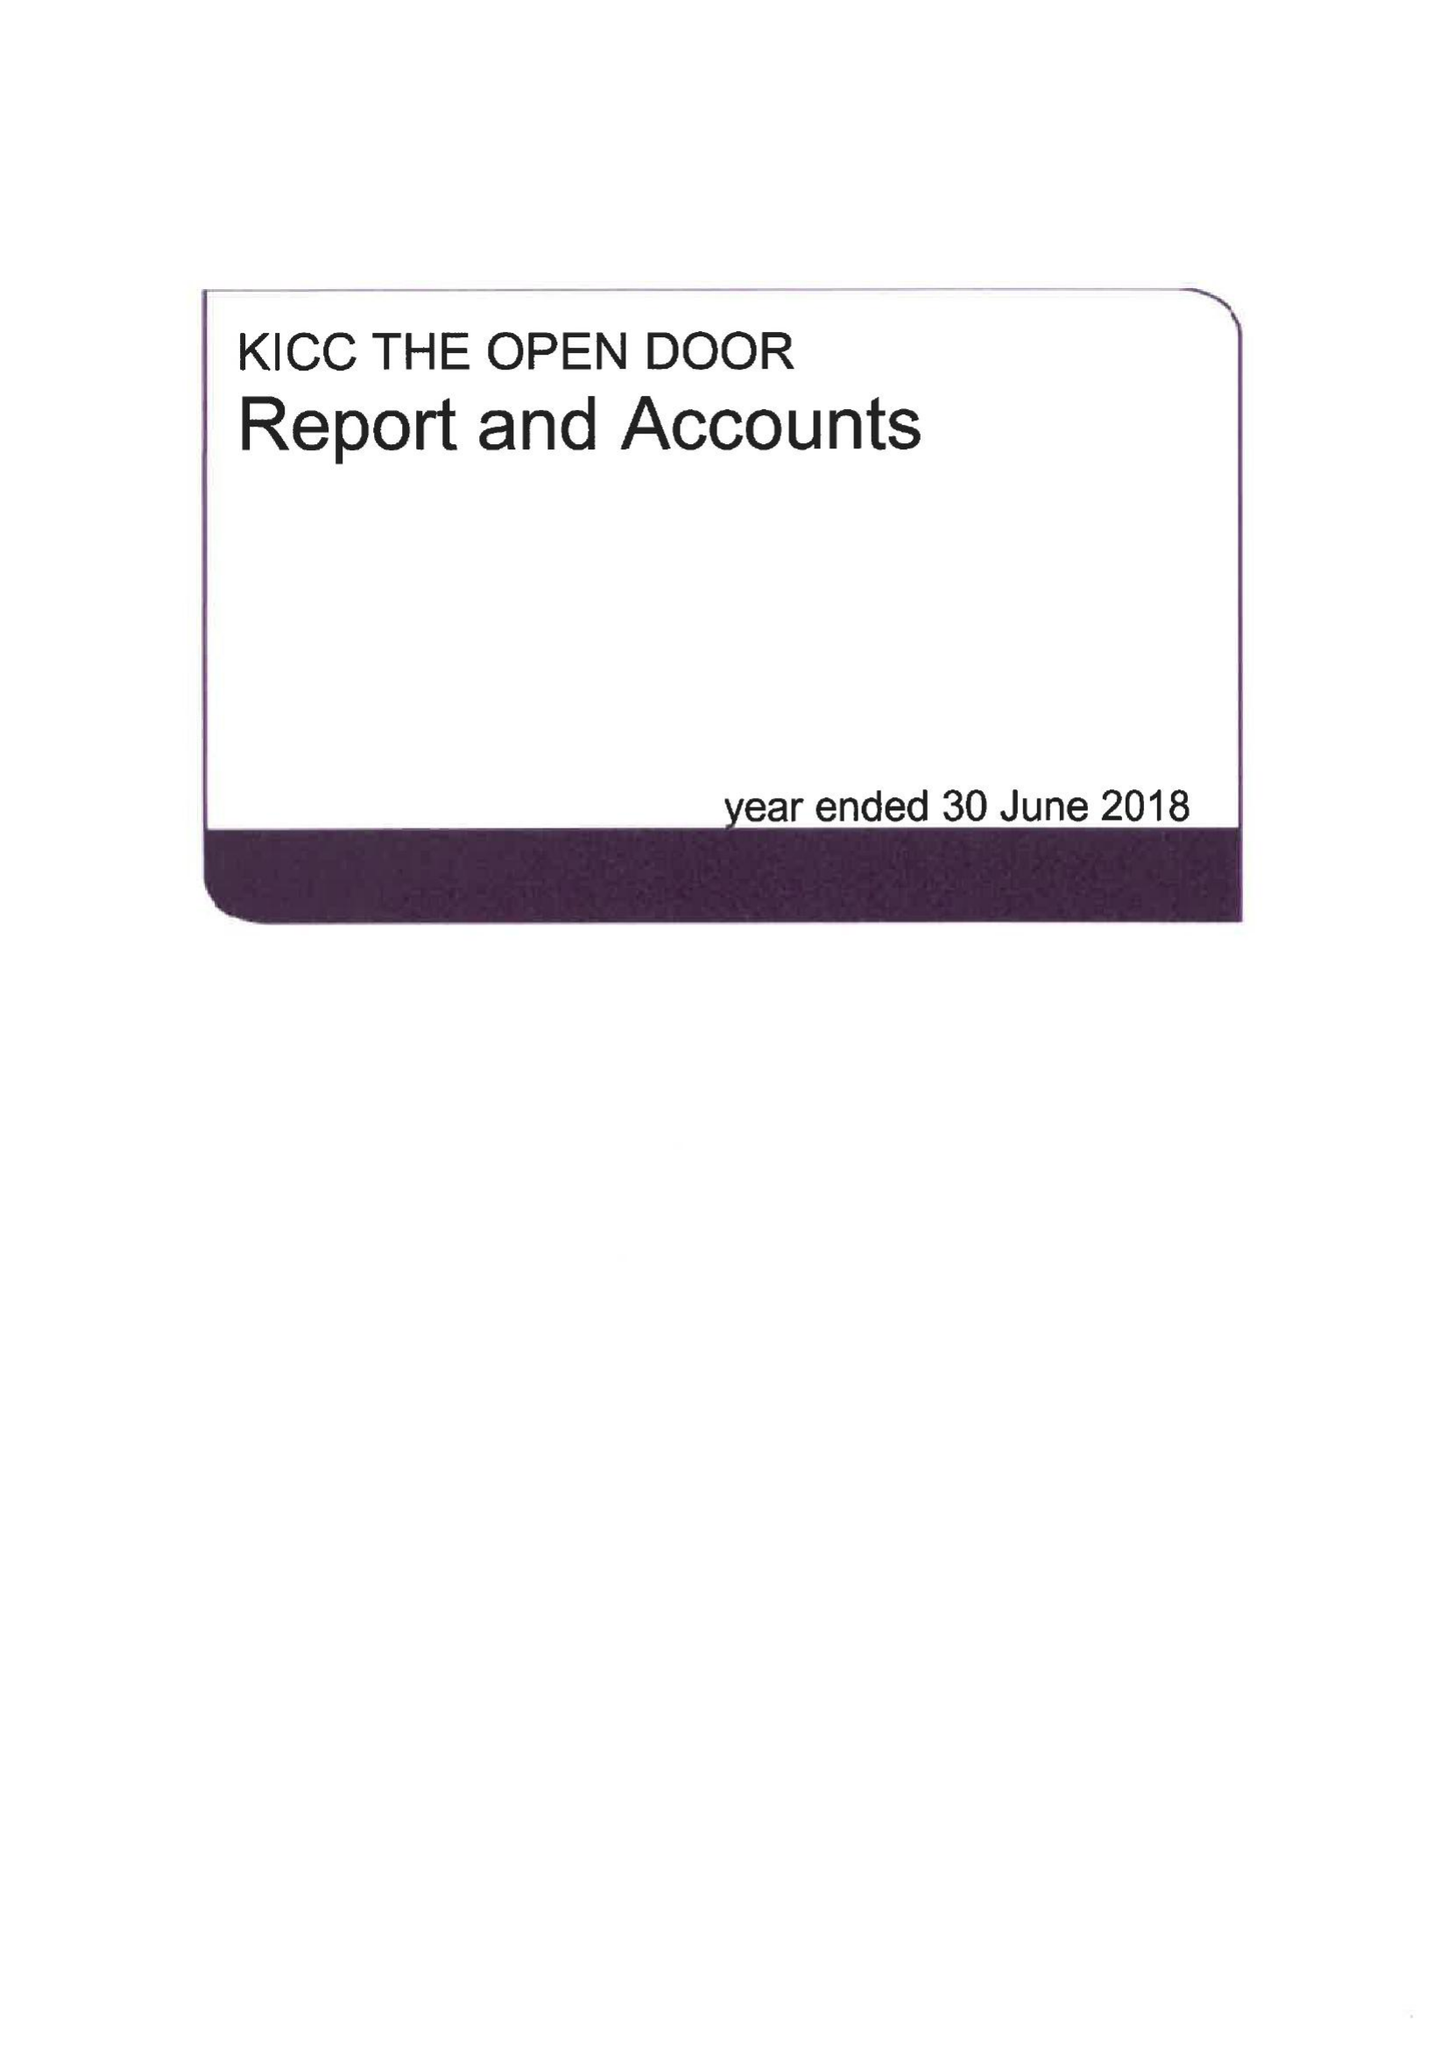What is the value for the address__postcode?
Answer the question using a single word or phrase. SW19 3TZ 